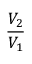<formula> <loc_0><loc_0><loc_500><loc_500>\frac { V _ { 2 } } { V _ { 1 } }</formula> 